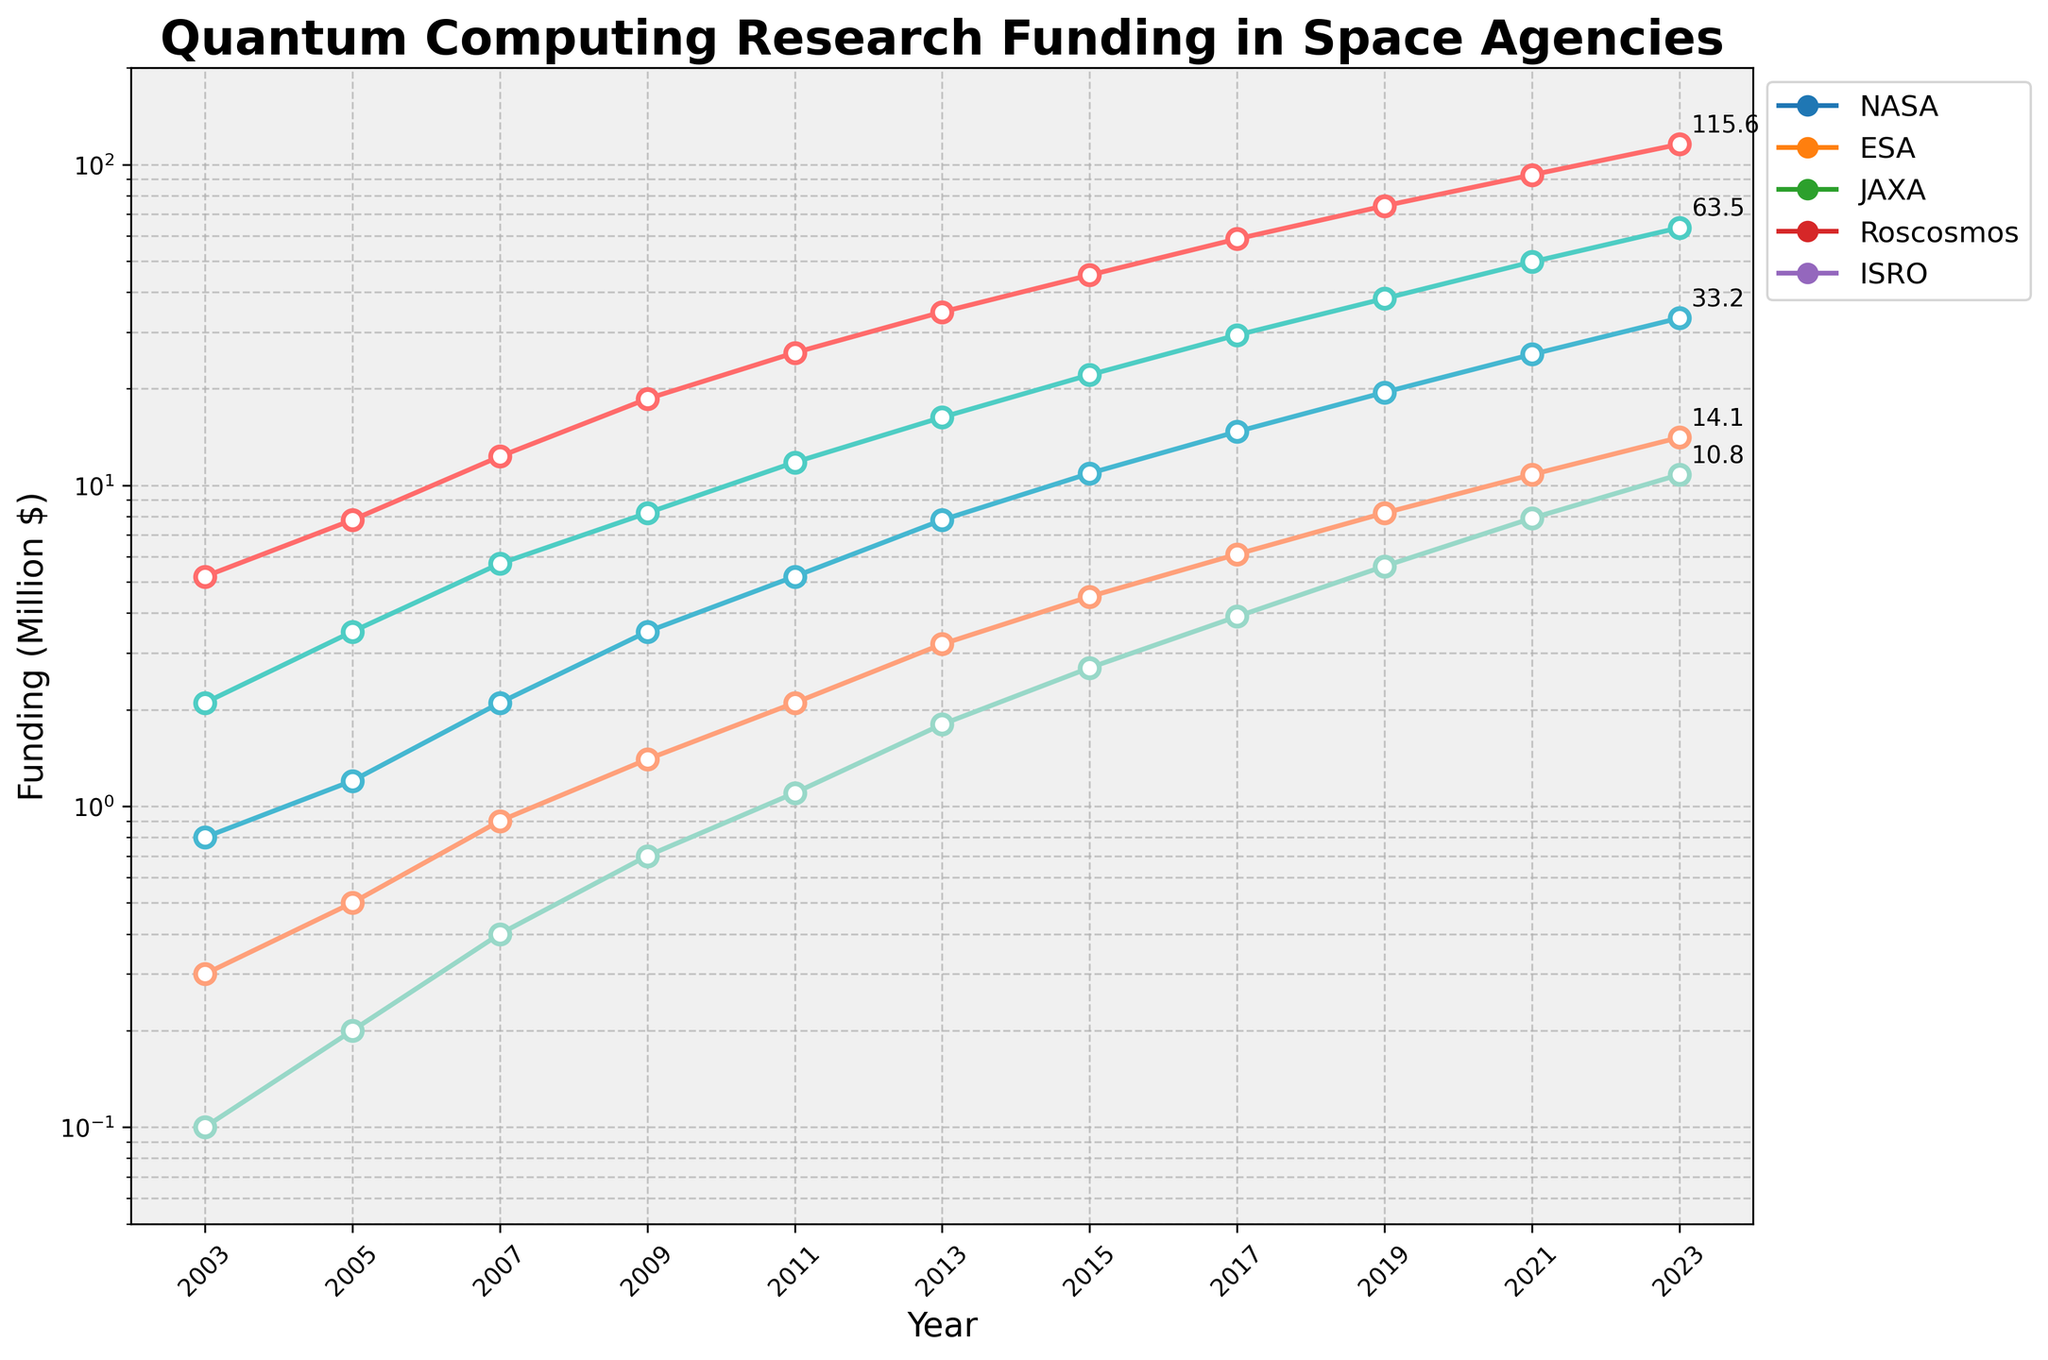Which space agency had the highest funding in 2023? By looking at the endpoints of each line on the chart, the highest point in 2023 corresponds to NASA.
Answer: NASA Which space agency had the least funding in 2003? By looking at the starting points of each line on the chart, the lowest point in 2003 corresponds to ISRO.
Answer: ISRO How much more funding did NASA have compared to ESA in 2023? First find the funding for NASA and ESA in 2023 (NASA: 115.6, ESA: 63.5), then calculate the difference: 115.6 - 63.5 = 52.1
Answer: 52.1 What is the average annual funding for ESA over the 20 years? Sum the funding values for ESA and divide by the number of years: (2.1 + 3.5 + 5.7 + 8.2 + 11.8 + 16.3 + 22.1 + 29.4 + 38.2 + 49.7 + 63.5)/11 ≈ 22.1
Answer: 22.1 Which two agencies showed the closest funding amounts in 2015, and what is the difference between them? First, find the funding amounts for all agencies in 2015: NASA (45.2), ESA (22.1), JAXA (10.9), Roscosmos (4.5), ISRO (2.7). The closest amounts are for JAXA and Roscosmos: 10.9 - 4.5 = 6.4
Answer: JAXA and Roscosmos, 6.4 Between which two consecutive years did NASA see the largest increase in funding? Compare year-to-year increases for NASA and find the largest: (2023-2021: 22.8, 2021-2019: 18.5, 2019-2017: 15.7, etc.). The largest increase is from 2021 to 2023 (92.8 to 115.6) = 22.8
Answer: 2021 to 2023 How many agencies had more than 10 million dollars in funding in 2023? Identify the agencies with values above 10 million in 2023: NASA (115.6), ESA (63.5), JAXA (33.2), Roscosmos (14.1), ISRO (10.8). All five agencies exceed 10 million.
Answer: 5 What is the trend in funding for JAXA from 2003 to 2023? Observe the line representing JAXA: it shows a consistent upward trend.
Answer: Upward trend Which agency’s funding trend line has the steepest slope indicating the fastest growth? By comparing the steepness of the lines, NASA’s line rises the quickest.
Answer: NASA 